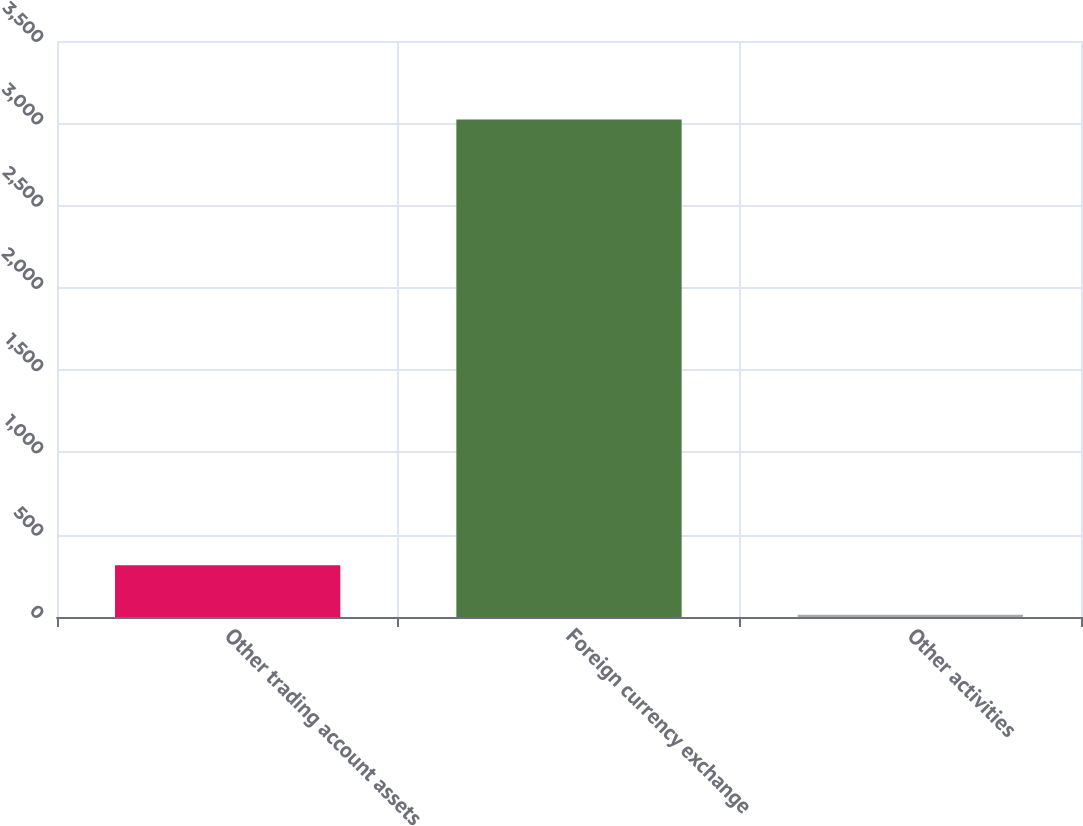Convert chart to OTSL. <chart><loc_0><loc_0><loc_500><loc_500><bar_chart><fcel>Other trading account assets<fcel>Foreign currency exchange<fcel>Other activities<nl><fcel>314<fcel>3023<fcel>13<nl></chart> 